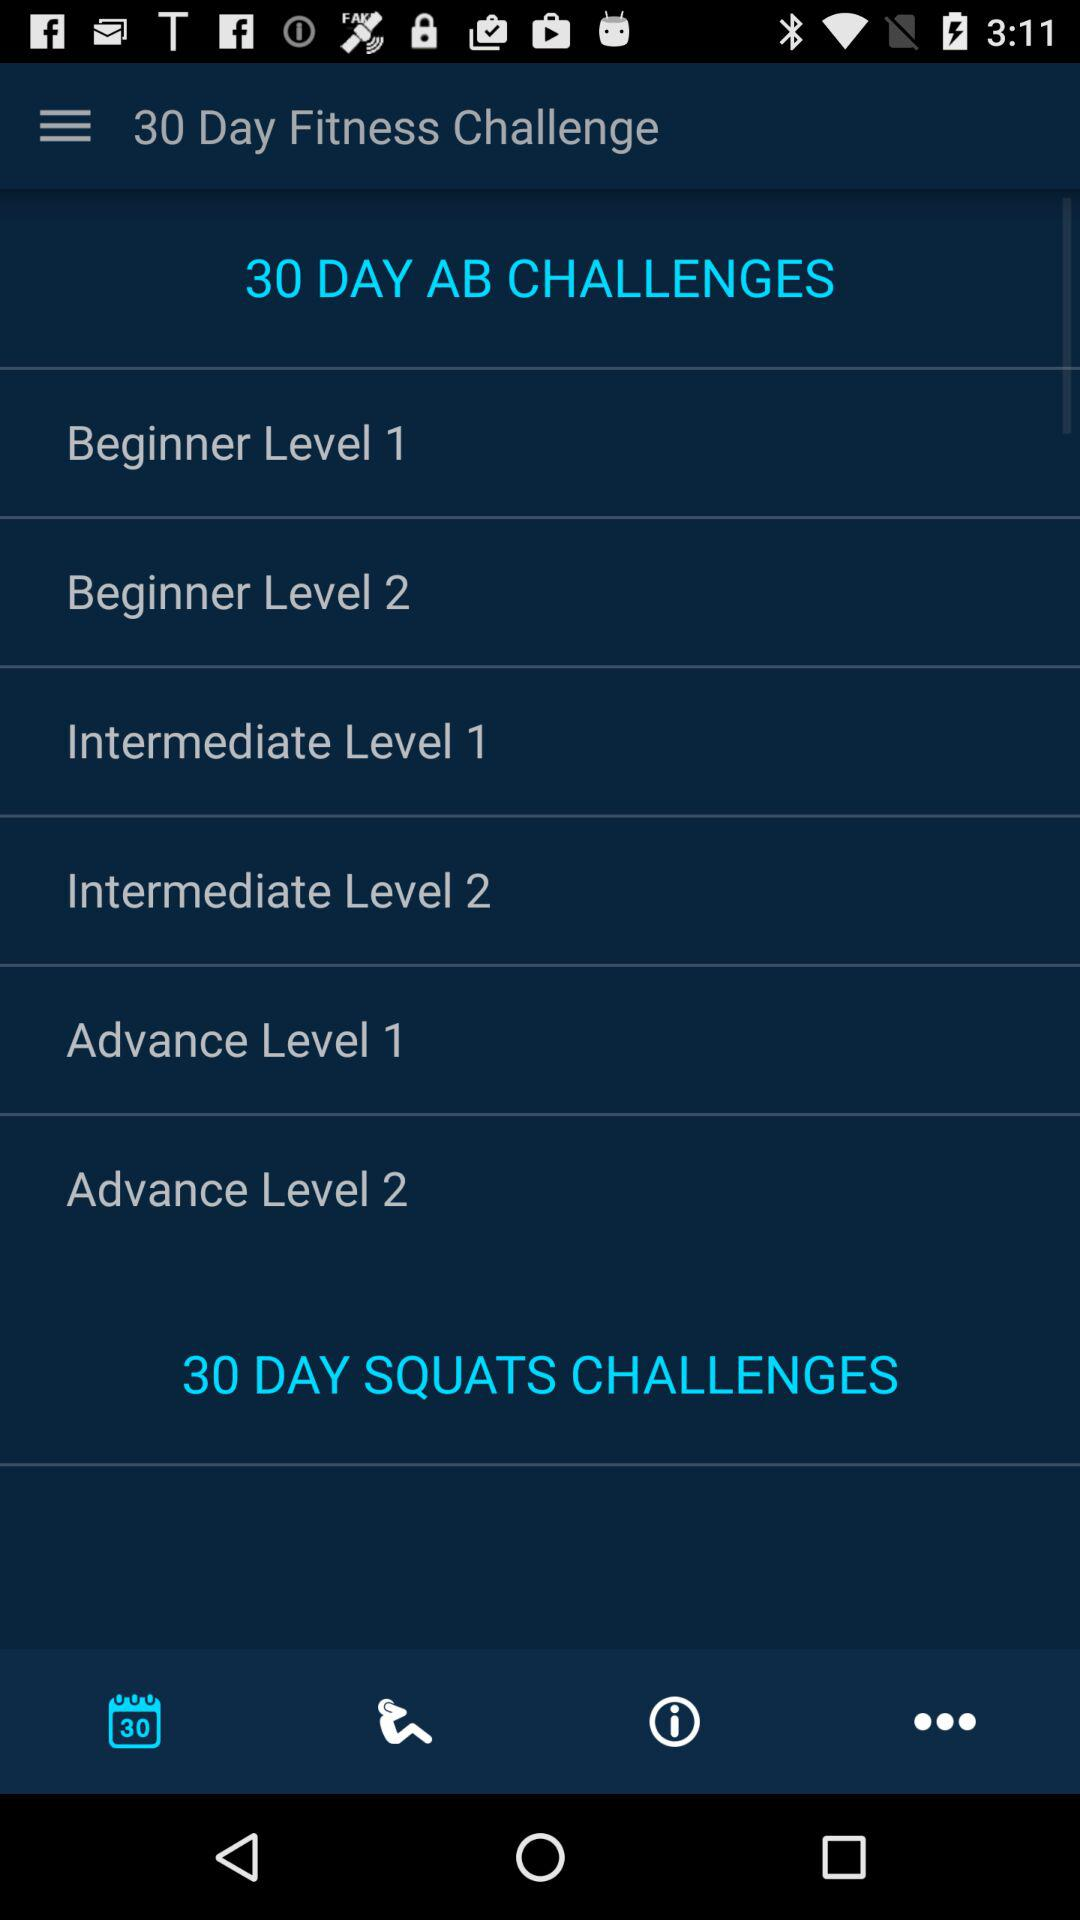How many days are there in the squat challenge? There are 30 days in the squat challenge. 